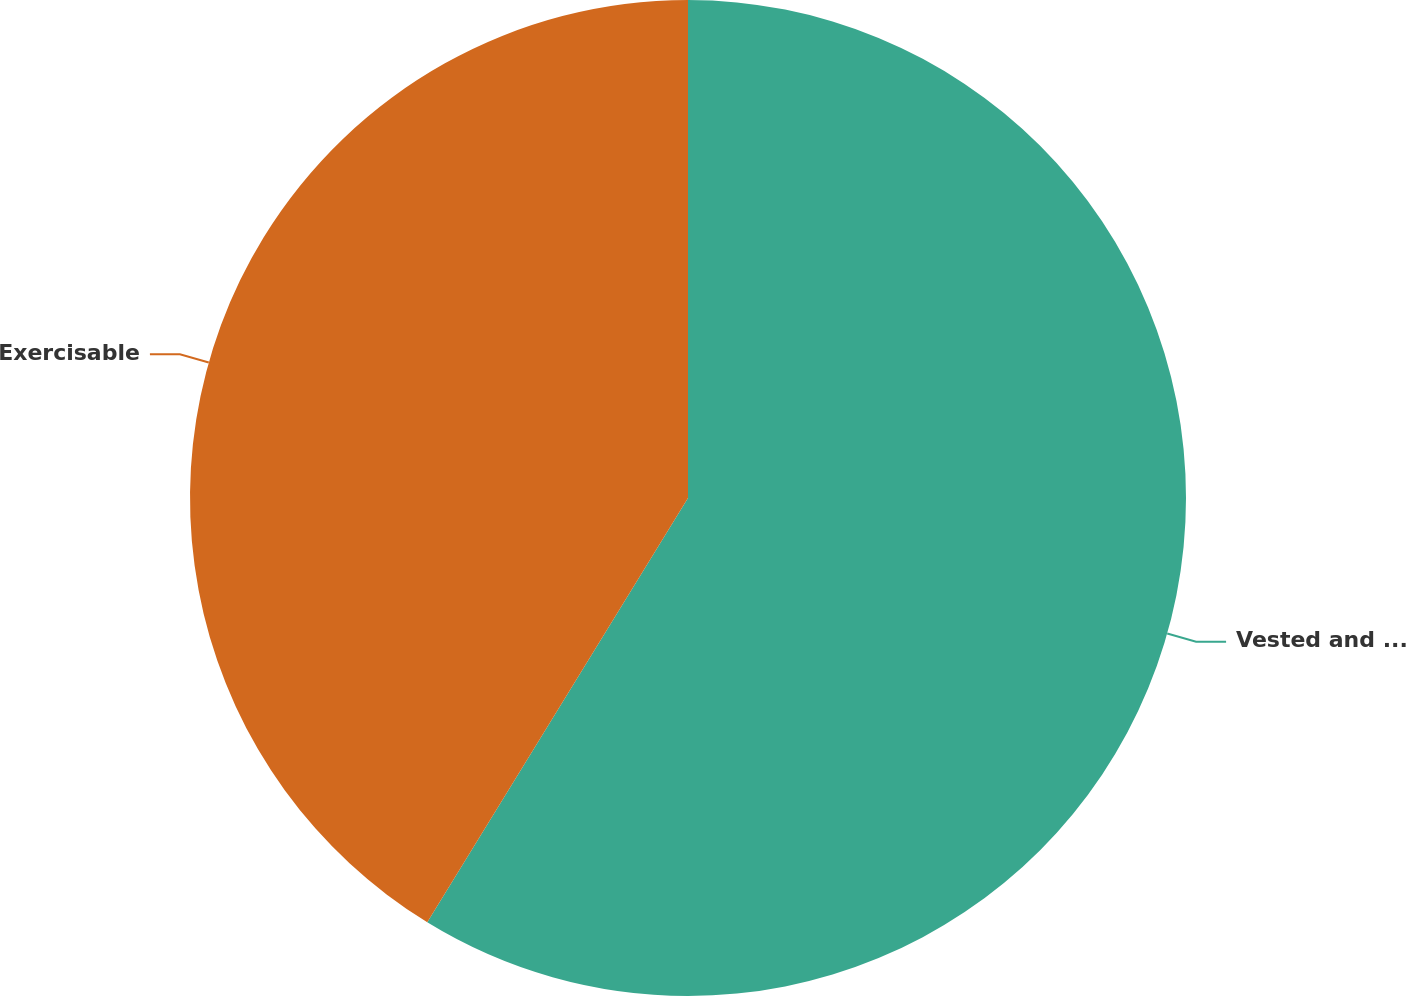Convert chart. <chart><loc_0><loc_0><loc_500><loc_500><pie_chart><fcel>Vested and expected to vest<fcel>Exercisable<nl><fcel>58.77%<fcel>41.23%<nl></chart> 